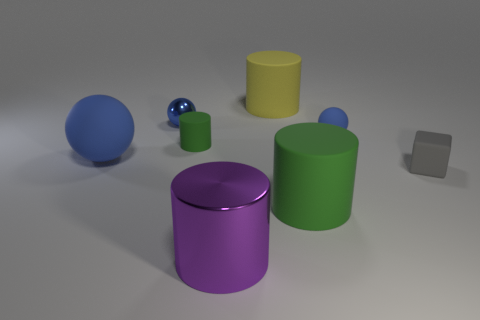There is a tiny cylinder; is its color the same as the large matte cylinder in front of the gray rubber block?
Make the answer very short. Yes. Is the number of small metal balls in front of the big green object the same as the number of big green matte cylinders right of the small gray matte block?
Offer a terse response. Yes. How many other things are the same size as the block?
Provide a short and direct response. 3. The purple shiny cylinder has what size?
Provide a succinct answer. Large. Do the small green object and the small blue thing left of the tiny rubber cylinder have the same material?
Provide a short and direct response. No. Are there any large brown objects that have the same shape as the yellow matte thing?
Provide a succinct answer. No. What is the material of the ball that is the same size as the purple thing?
Provide a succinct answer. Rubber. What size is the blue object that is to the right of the tiny metal object?
Offer a very short reply. Small. There is a block that is to the right of the big matte sphere; is its size the same as the blue sphere that is to the right of the small green matte cylinder?
Offer a very short reply. Yes. How many small green blocks have the same material as the big green thing?
Give a very brief answer. 0. 